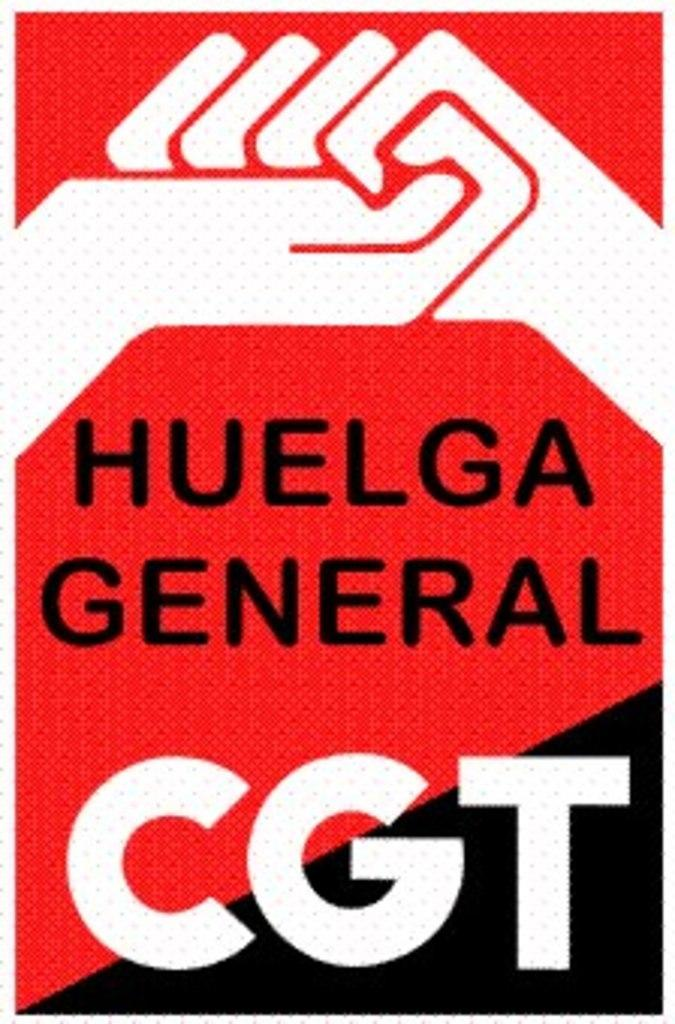Provide a one-sentence caption for the provided image. a poster that says 'huelga general cgt' with black and red and white on it. 